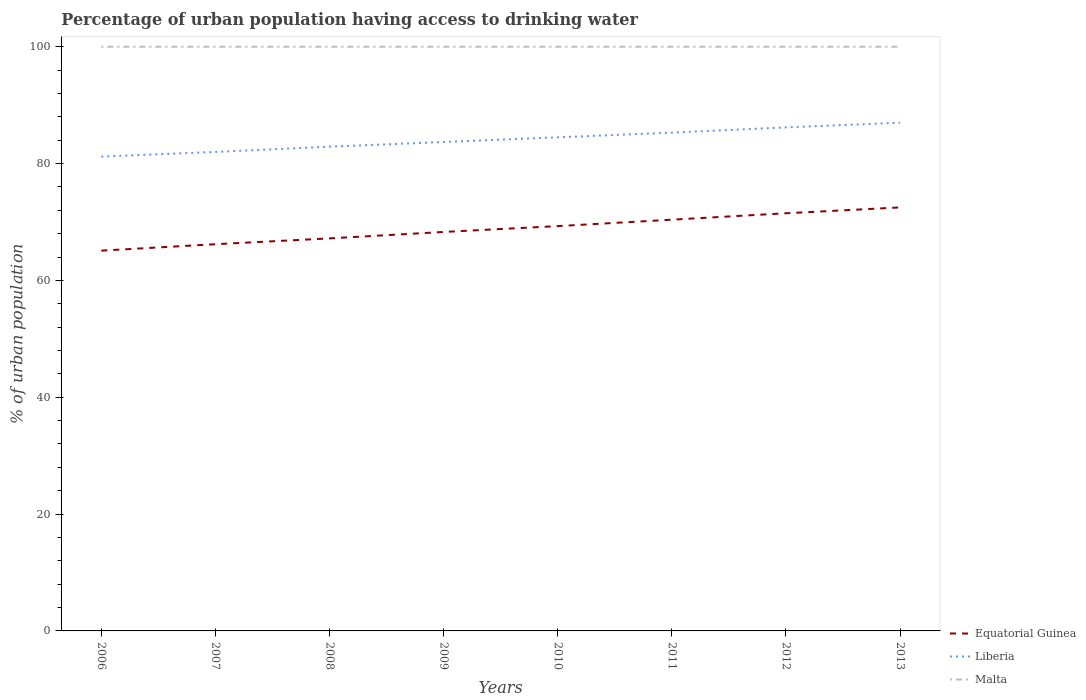Across all years, what is the maximum percentage of urban population having access to drinking water in Liberia?
Provide a succinct answer. 81.2. What is the total percentage of urban population having access to drinking water in Liberia in the graph?
Give a very brief answer. -1.7. What is the difference between the highest and the second highest percentage of urban population having access to drinking water in Liberia?
Give a very brief answer. 5.8. What is the difference between the highest and the lowest percentage of urban population having access to drinking water in Equatorial Guinea?
Your answer should be compact. 4. Is the percentage of urban population having access to drinking water in Malta strictly greater than the percentage of urban population having access to drinking water in Liberia over the years?
Keep it short and to the point. No. How many lines are there?
Offer a very short reply. 3. How many years are there in the graph?
Offer a very short reply. 8. Where does the legend appear in the graph?
Your answer should be compact. Bottom right. What is the title of the graph?
Provide a succinct answer. Percentage of urban population having access to drinking water. What is the label or title of the X-axis?
Offer a very short reply. Years. What is the label or title of the Y-axis?
Give a very brief answer. % of urban population. What is the % of urban population in Equatorial Guinea in 2006?
Ensure brevity in your answer.  65.1. What is the % of urban population in Liberia in 2006?
Offer a terse response. 81.2. What is the % of urban population of Malta in 2006?
Your answer should be compact. 100. What is the % of urban population in Equatorial Guinea in 2007?
Provide a succinct answer. 66.2. What is the % of urban population in Malta in 2007?
Ensure brevity in your answer.  100. What is the % of urban population of Equatorial Guinea in 2008?
Your response must be concise. 67.2. What is the % of urban population of Liberia in 2008?
Your answer should be very brief. 82.9. What is the % of urban population in Equatorial Guinea in 2009?
Your answer should be compact. 68.3. What is the % of urban population in Liberia in 2009?
Your answer should be very brief. 83.7. What is the % of urban population in Equatorial Guinea in 2010?
Your answer should be very brief. 69.3. What is the % of urban population of Liberia in 2010?
Keep it short and to the point. 84.5. What is the % of urban population of Equatorial Guinea in 2011?
Your answer should be compact. 70.4. What is the % of urban population in Liberia in 2011?
Offer a very short reply. 85.3. What is the % of urban population of Equatorial Guinea in 2012?
Provide a short and direct response. 71.5. What is the % of urban population of Liberia in 2012?
Your answer should be very brief. 86.2. What is the % of urban population of Malta in 2012?
Your response must be concise. 100. What is the % of urban population of Equatorial Guinea in 2013?
Your answer should be very brief. 72.5. What is the % of urban population in Liberia in 2013?
Your answer should be compact. 87. What is the % of urban population of Malta in 2013?
Make the answer very short. 100. Across all years, what is the maximum % of urban population in Equatorial Guinea?
Offer a very short reply. 72.5. Across all years, what is the maximum % of urban population of Malta?
Provide a succinct answer. 100. Across all years, what is the minimum % of urban population of Equatorial Guinea?
Offer a very short reply. 65.1. Across all years, what is the minimum % of urban population in Liberia?
Offer a very short reply. 81.2. What is the total % of urban population of Equatorial Guinea in the graph?
Offer a very short reply. 550.5. What is the total % of urban population in Liberia in the graph?
Make the answer very short. 672.8. What is the total % of urban population in Malta in the graph?
Your response must be concise. 800. What is the difference between the % of urban population in Malta in 2006 and that in 2007?
Offer a very short reply. 0. What is the difference between the % of urban population of Equatorial Guinea in 2006 and that in 2008?
Ensure brevity in your answer.  -2.1. What is the difference between the % of urban population of Malta in 2006 and that in 2008?
Provide a succinct answer. 0. What is the difference between the % of urban population of Malta in 2006 and that in 2009?
Your answer should be compact. 0. What is the difference between the % of urban population in Equatorial Guinea in 2006 and that in 2011?
Make the answer very short. -5.3. What is the difference between the % of urban population of Equatorial Guinea in 2006 and that in 2012?
Your response must be concise. -6.4. What is the difference between the % of urban population of Malta in 2006 and that in 2012?
Your response must be concise. 0. What is the difference between the % of urban population in Equatorial Guinea in 2006 and that in 2013?
Your answer should be very brief. -7.4. What is the difference between the % of urban population in Liberia in 2006 and that in 2013?
Your response must be concise. -5.8. What is the difference between the % of urban population in Malta in 2006 and that in 2013?
Keep it short and to the point. 0. What is the difference between the % of urban population in Equatorial Guinea in 2007 and that in 2008?
Provide a succinct answer. -1. What is the difference between the % of urban population of Malta in 2007 and that in 2008?
Provide a succinct answer. 0. What is the difference between the % of urban population in Malta in 2007 and that in 2009?
Your response must be concise. 0. What is the difference between the % of urban population of Equatorial Guinea in 2007 and that in 2011?
Your response must be concise. -4.2. What is the difference between the % of urban population in Liberia in 2007 and that in 2011?
Make the answer very short. -3.3. What is the difference between the % of urban population of Malta in 2007 and that in 2011?
Offer a terse response. 0. What is the difference between the % of urban population of Equatorial Guinea in 2007 and that in 2012?
Your answer should be very brief. -5.3. What is the difference between the % of urban population in Equatorial Guinea in 2007 and that in 2013?
Ensure brevity in your answer.  -6.3. What is the difference between the % of urban population of Liberia in 2007 and that in 2013?
Provide a short and direct response. -5. What is the difference between the % of urban population in Malta in 2007 and that in 2013?
Your answer should be compact. 0. What is the difference between the % of urban population in Equatorial Guinea in 2008 and that in 2009?
Provide a short and direct response. -1.1. What is the difference between the % of urban population in Liberia in 2008 and that in 2009?
Offer a very short reply. -0.8. What is the difference between the % of urban population in Equatorial Guinea in 2008 and that in 2010?
Give a very brief answer. -2.1. What is the difference between the % of urban population of Liberia in 2008 and that in 2010?
Provide a short and direct response. -1.6. What is the difference between the % of urban population of Malta in 2008 and that in 2010?
Provide a succinct answer. 0. What is the difference between the % of urban population of Equatorial Guinea in 2008 and that in 2011?
Provide a short and direct response. -3.2. What is the difference between the % of urban population in Equatorial Guinea in 2008 and that in 2012?
Your response must be concise. -4.3. What is the difference between the % of urban population in Equatorial Guinea in 2008 and that in 2013?
Your answer should be compact. -5.3. What is the difference between the % of urban population of Equatorial Guinea in 2009 and that in 2010?
Provide a short and direct response. -1. What is the difference between the % of urban population of Malta in 2009 and that in 2010?
Provide a succinct answer. 0. What is the difference between the % of urban population of Malta in 2009 and that in 2011?
Your answer should be very brief. 0. What is the difference between the % of urban population in Liberia in 2009 and that in 2012?
Ensure brevity in your answer.  -2.5. What is the difference between the % of urban population of Equatorial Guinea in 2009 and that in 2013?
Offer a very short reply. -4.2. What is the difference between the % of urban population of Liberia in 2009 and that in 2013?
Provide a short and direct response. -3.3. What is the difference between the % of urban population of Equatorial Guinea in 2010 and that in 2011?
Ensure brevity in your answer.  -1.1. What is the difference between the % of urban population of Equatorial Guinea in 2010 and that in 2012?
Offer a terse response. -2.2. What is the difference between the % of urban population in Liberia in 2010 and that in 2012?
Your response must be concise. -1.7. What is the difference between the % of urban population of Malta in 2010 and that in 2012?
Keep it short and to the point. 0. What is the difference between the % of urban population in Malta in 2010 and that in 2013?
Provide a succinct answer. 0. What is the difference between the % of urban population of Liberia in 2011 and that in 2012?
Provide a short and direct response. -0.9. What is the difference between the % of urban population in Malta in 2011 and that in 2012?
Your response must be concise. 0. What is the difference between the % of urban population in Equatorial Guinea in 2011 and that in 2013?
Offer a very short reply. -2.1. What is the difference between the % of urban population in Liberia in 2011 and that in 2013?
Give a very brief answer. -1.7. What is the difference between the % of urban population in Equatorial Guinea in 2006 and the % of urban population in Liberia in 2007?
Your answer should be compact. -16.9. What is the difference between the % of urban population in Equatorial Guinea in 2006 and the % of urban population in Malta in 2007?
Provide a succinct answer. -34.9. What is the difference between the % of urban population in Liberia in 2006 and the % of urban population in Malta in 2007?
Ensure brevity in your answer.  -18.8. What is the difference between the % of urban population of Equatorial Guinea in 2006 and the % of urban population of Liberia in 2008?
Your response must be concise. -17.8. What is the difference between the % of urban population in Equatorial Guinea in 2006 and the % of urban population in Malta in 2008?
Provide a short and direct response. -34.9. What is the difference between the % of urban population of Liberia in 2006 and the % of urban population of Malta in 2008?
Your answer should be very brief. -18.8. What is the difference between the % of urban population in Equatorial Guinea in 2006 and the % of urban population in Liberia in 2009?
Offer a terse response. -18.6. What is the difference between the % of urban population in Equatorial Guinea in 2006 and the % of urban population in Malta in 2009?
Give a very brief answer. -34.9. What is the difference between the % of urban population of Liberia in 2006 and the % of urban population of Malta in 2009?
Provide a short and direct response. -18.8. What is the difference between the % of urban population in Equatorial Guinea in 2006 and the % of urban population in Liberia in 2010?
Provide a short and direct response. -19.4. What is the difference between the % of urban population of Equatorial Guinea in 2006 and the % of urban population of Malta in 2010?
Your answer should be very brief. -34.9. What is the difference between the % of urban population of Liberia in 2006 and the % of urban population of Malta in 2010?
Offer a terse response. -18.8. What is the difference between the % of urban population in Equatorial Guinea in 2006 and the % of urban population in Liberia in 2011?
Give a very brief answer. -20.2. What is the difference between the % of urban population in Equatorial Guinea in 2006 and the % of urban population in Malta in 2011?
Provide a succinct answer. -34.9. What is the difference between the % of urban population in Liberia in 2006 and the % of urban population in Malta in 2011?
Your answer should be very brief. -18.8. What is the difference between the % of urban population in Equatorial Guinea in 2006 and the % of urban population in Liberia in 2012?
Offer a terse response. -21.1. What is the difference between the % of urban population in Equatorial Guinea in 2006 and the % of urban population in Malta in 2012?
Offer a very short reply. -34.9. What is the difference between the % of urban population of Liberia in 2006 and the % of urban population of Malta in 2012?
Your response must be concise. -18.8. What is the difference between the % of urban population in Equatorial Guinea in 2006 and the % of urban population in Liberia in 2013?
Give a very brief answer. -21.9. What is the difference between the % of urban population in Equatorial Guinea in 2006 and the % of urban population in Malta in 2013?
Provide a short and direct response. -34.9. What is the difference between the % of urban population in Liberia in 2006 and the % of urban population in Malta in 2013?
Offer a terse response. -18.8. What is the difference between the % of urban population of Equatorial Guinea in 2007 and the % of urban population of Liberia in 2008?
Keep it short and to the point. -16.7. What is the difference between the % of urban population in Equatorial Guinea in 2007 and the % of urban population in Malta in 2008?
Keep it short and to the point. -33.8. What is the difference between the % of urban population of Liberia in 2007 and the % of urban population of Malta in 2008?
Keep it short and to the point. -18. What is the difference between the % of urban population in Equatorial Guinea in 2007 and the % of urban population in Liberia in 2009?
Provide a succinct answer. -17.5. What is the difference between the % of urban population of Equatorial Guinea in 2007 and the % of urban population of Malta in 2009?
Make the answer very short. -33.8. What is the difference between the % of urban population in Liberia in 2007 and the % of urban population in Malta in 2009?
Keep it short and to the point. -18. What is the difference between the % of urban population in Equatorial Guinea in 2007 and the % of urban population in Liberia in 2010?
Offer a terse response. -18.3. What is the difference between the % of urban population of Equatorial Guinea in 2007 and the % of urban population of Malta in 2010?
Your response must be concise. -33.8. What is the difference between the % of urban population in Liberia in 2007 and the % of urban population in Malta in 2010?
Keep it short and to the point. -18. What is the difference between the % of urban population in Equatorial Guinea in 2007 and the % of urban population in Liberia in 2011?
Offer a very short reply. -19.1. What is the difference between the % of urban population of Equatorial Guinea in 2007 and the % of urban population of Malta in 2011?
Provide a short and direct response. -33.8. What is the difference between the % of urban population of Liberia in 2007 and the % of urban population of Malta in 2011?
Ensure brevity in your answer.  -18. What is the difference between the % of urban population of Equatorial Guinea in 2007 and the % of urban population of Malta in 2012?
Ensure brevity in your answer.  -33.8. What is the difference between the % of urban population in Liberia in 2007 and the % of urban population in Malta in 2012?
Your answer should be compact. -18. What is the difference between the % of urban population in Equatorial Guinea in 2007 and the % of urban population in Liberia in 2013?
Your answer should be very brief. -20.8. What is the difference between the % of urban population in Equatorial Guinea in 2007 and the % of urban population in Malta in 2013?
Keep it short and to the point. -33.8. What is the difference between the % of urban population of Liberia in 2007 and the % of urban population of Malta in 2013?
Your answer should be compact. -18. What is the difference between the % of urban population of Equatorial Guinea in 2008 and the % of urban population of Liberia in 2009?
Your response must be concise. -16.5. What is the difference between the % of urban population of Equatorial Guinea in 2008 and the % of urban population of Malta in 2009?
Make the answer very short. -32.8. What is the difference between the % of urban population in Liberia in 2008 and the % of urban population in Malta in 2009?
Offer a very short reply. -17.1. What is the difference between the % of urban population in Equatorial Guinea in 2008 and the % of urban population in Liberia in 2010?
Your response must be concise. -17.3. What is the difference between the % of urban population of Equatorial Guinea in 2008 and the % of urban population of Malta in 2010?
Give a very brief answer. -32.8. What is the difference between the % of urban population in Liberia in 2008 and the % of urban population in Malta in 2010?
Provide a succinct answer. -17.1. What is the difference between the % of urban population of Equatorial Guinea in 2008 and the % of urban population of Liberia in 2011?
Your answer should be compact. -18.1. What is the difference between the % of urban population in Equatorial Guinea in 2008 and the % of urban population in Malta in 2011?
Keep it short and to the point. -32.8. What is the difference between the % of urban population in Liberia in 2008 and the % of urban population in Malta in 2011?
Ensure brevity in your answer.  -17.1. What is the difference between the % of urban population of Equatorial Guinea in 2008 and the % of urban population of Malta in 2012?
Provide a succinct answer. -32.8. What is the difference between the % of urban population of Liberia in 2008 and the % of urban population of Malta in 2012?
Offer a very short reply. -17.1. What is the difference between the % of urban population of Equatorial Guinea in 2008 and the % of urban population of Liberia in 2013?
Your answer should be compact. -19.8. What is the difference between the % of urban population of Equatorial Guinea in 2008 and the % of urban population of Malta in 2013?
Keep it short and to the point. -32.8. What is the difference between the % of urban population of Liberia in 2008 and the % of urban population of Malta in 2013?
Your answer should be very brief. -17.1. What is the difference between the % of urban population of Equatorial Guinea in 2009 and the % of urban population of Liberia in 2010?
Your response must be concise. -16.2. What is the difference between the % of urban population of Equatorial Guinea in 2009 and the % of urban population of Malta in 2010?
Ensure brevity in your answer.  -31.7. What is the difference between the % of urban population in Liberia in 2009 and the % of urban population in Malta in 2010?
Your answer should be very brief. -16.3. What is the difference between the % of urban population in Equatorial Guinea in 2009 and the % of urban population in Liberia in 2011?
Ensure brevity in your answer.  -17. What is the difference between the % of urban population of Equatorial Guinea in 2009 and the % of urban population of Malta in 2011?
Your answer should be very brief. -31.7. What is the difference between the % of urban population of Liberia in 2009 and the % of urban population of Malta in 2011?
Your answer should be very brief. -16.3. What is the difference between the % of urban population in Equatorial Guinea in 2009 and the % of urban population in Liberia in 2012?
Keep it short and to the point. -17.9. What is the difference between the % of urban population in Equatorial Guinea in 2009 and the % of urban population in Malta in 2012?
Ensure brevity in your answer.  -31.7. What is the difference between the % of urban population in Liberia in 2009 and the % of urban population in Malta in 2012?
Make the answer very short. -16.3. What is the difference between the % of urban population of Equatorial Guinea in 2009 and the % of urban population of Liberia in 2013?
Offer a terse response. -18.7. What is the difference between the % of urban population of Equatorial Guinea in 2009 and the % of urban population of Malta in 2013?
Give a very brief answer. -31.7. What is the difference between the % of urban population of Liberia in 2009 and the % of urban population of Malta in 2013?
Make the answer very short. -16.3. What is the difference between the % of urban population in Equatorial Guinea in 2010 and the % of urban population in Malta in 2011?
Ensure brevity in your answer.  -30.7. What is the difference between the % of urban population in Liberia in 2010 and the % of urban population in Malta in 2011?
Your response must be concise. -15.5. What is the difference between the % of urban population of Equatorial Guinea in 2010 and the % of urban population of Liberia in 2012?
Offer a very short reply. -16.9. What is the difference between the % of urban population in Equatorial Guinea in 2010 and the % of urban population in Malta in 2012?
Your answer should be very brief. -30.7. What is the difference between the % of urban population of Liberia in 2010 and the % of urban population of Malta in 2012?
Offer a terse response. -15.5. What is the difference between the % of urban population of Equatorial Guinea in 2010 and the % of urban population of Liberia in 2013?
Your answer should be compact. -17.7. What is the difference between the % of urban population in Equatorial Guinea in 2010 and the % of urban population in Malta in 2013?
Ensure brevity in your answer.  -30.7. What is the difference between the % of urban population in Liberia in 2010 and the % of urban population in Malta in 2013?
Provide a succinct answer. -15.5. What is the difference between the % of urban population in Equatorial Guinea in 2011 and the % of urban population in Liberia in 2012?
Your answer should be compact. -15.8. What is the difference between the % of urban population in Equatorial Guinea in 2011 and the % of urban population in Malta in 2012?
Provide a short and direct response. -29.6. What is the difference between the % of urban population of Liberia in 2011 and the % of urban population of Malta in 2012?
Your response must be concise. -14.7. What is the difference between the % of urban population of Equatorial Guinea in 2011 and the % of urban population of Liberia in 2013?
Your answer should be compact. -16.6. What is the difference between the % of urban population in Equatorial Guinea in 2011 and the % of urban population in Malta in 2013?
Your answer should be very brief. -29.6. What is the difference between the % of urban population of Liberia in 2011 and the % of urban population of Malta in 2013?
Keep it short and to the point. -14.7. What is the difference between the % of urban population of Equatorial Guinea in 2012 and the % of urban population of Liberia in 2013?
Keep it short and to the point. -15.5. What is the difference between the % of urban population in Equatorial Guinea in 2012 and the % of urban population in Malta in 2013?
Provide a short and direct response. -28.5. What is the average % of urban population in Equatorial Guinea per year?
Offer a terse response. 68.81. What is the average % of urban population of Liberia per year?
Your answer should be very brief. 84.1. What is the average % of urban population of Malta per year?
Offer a very short reply. 100. In the year 2006, what is the difference between the % of urban population in Equatorial Guinea and % of urban population in Liberia?
Your answer should be very brief. -16.1. In the year 2006, what is the difference between the % of urban population of Equatorial Guinea and % of urban population of Malta?
Give a very brief answer. -34.9. In the year 2006, what is the difference between the % of urban population of Liberia and % of urban population of Malta?
Offer a very short reply. -18.8. In the year 2007, what is the difference between the % of urban population of Equatorial Guinea and % of urban population of Liberia?
Provide a short and direct response. -15.8. In the year 2007, what is the difference between the % of urban population in Equatorial Guinea and % of urban population in Malta?
Keep it short and to the point. -33.8. In the year 2008, what is the difference between the % of urban population in Equatorial Guinea and % of urban population in Liberia?
Make the answer very short. -15.7. In the year 2008, what is the difference between the % of urban population of Equatorial Guinea and % of urban population of Malta?
Make the answer very short. -32.8. In the year 2008, what is the difference between the % of urban population in Liberia and % of urban population in Malta?
Offer a terse response. -17.1. In the year 2009, what is the difference between the % of urban population of Equatorial Guinea and % of urban population of Liberia?
Make the answer very short. -15.4. In the year 2009, what is the difference between the % of urban population in Equatorial Guinea and % of urban population in Malta?
Your answer should be very brief. -31.7. In the year 2009, what is the difference between the % of urban population of Liberia and % of urban population of Malta?
Your response must be concise. -16.3. In the year 2010, what is the difference between the % of urban population of Equatorial Guinea and % of urban population of Liberia?
Your answer should be very brief. -15.2. In the year 2010, what is the difference between the % of urban population of Equatorial Guinea and % of urban population of Malta?
Make the answer very short. -30.7. In the year 2010, what is the difference between the % of urban population in Liberia and % of urban population in Malta?
Offer a terse response. -15.5. In the year 2011, what is the difference between the % of urban population in Equatorial Guinea and % of urban population in Liberia?
Your response must be concise. -14.9. In the year 2011, what is the difference between the % of urban population of Equatorial Guinea and % of urban population of Malta?
Provide a succinct answer. -29.6. In the year 2011, what is the difference between the % of urban population of Liberia and % of urban population of Malta?
Keep it short and to the point. -14.7. In the year 2012, what is the difference between the % of urban population in Equatorial Guinea and % of urban population in Liberia?
Keep it short and to the point. -14.7. In the year 2012, what is the difference between the % of urban population of Equatorial Guinea and % of urban population of Malta?
Your answer should be compact. -28.5. In the year 2012, what is the difference between the % of urban population of Liberia and % of urban population of Malta?
Ensure brevity in your answer.  -13.8. In the year 2013, what is the difference between the % of urban population of Equatorial Guinea and % of urban population of Liberia?
Offer a terse response. -14.5. In the year 2013, what is the difference between the % of urban population of Equatorial Guinea and % of urban population of Malta?
Ensure brevity in your answer.  -27.5. What is the ratio of the % of urban population of Equatorial Guinea in 2006 to that in 2007?
Your answer should be compact. 0.98. What is the ratio of the % of urban population in Liberia in 2006 to that in 2007?
Your answer should be very brief. 0.99. What is the ratio of the % of urban population of Malta in 2006 to that in 2007?
Offer a terse response. 1. What is the ratio of the % of urban population of Equatorial Guinea in 2006 to that in 2008?
Make the answer very short. 0.97. What is the ratio of the % of urban population in Liberia in 2006 to that in 2008?
Your answer should be compact. 0.98. What is the ratio of the % of urban population in Malta in 2006 to that in 2008?
Provide a short and direct response. 1. What is the ratio of the % of urban population in Equatorial Guinea in 2006 to that in 2009?
Your response must be concise. 0.95. What is the ratio of the % of urban population in Liberia in 2006 to that in 2009?
Keep it short and to the point. 0.97. What is the ratio of the % of urban population of Malta in 2006 to that in 2009?
Your answer should be compact. 1. What is the ratio of the % of urban population of Equatorial Guinea in 2006 to that in 2010?
Provide a short and direct response. 0.94. What is the ratio of the % of urban population of Liberia in 2006 to that in 2010?
Your response must be concise. 0.96. What is the ratio of the % of urban population of Malta in 2006 to that in 2010?
Give a very brief answer. 1. What is the ratio of the % of urban population of Equatorial Guinea in 2006 to that in 2011?
Ensure brevity in your answer.  0.92. What is the ratio of the % of urban population of Liberia in 2006 to that in 2011?
Keep it short and to the point. 0.95. What is the ratio of the % of urban population in Malta in 2006 to that in 2011?
Your answer should be compact. 1. What is the ratio of the % of urban population in Equatorial Guinea in 2006 to that in 2012?
Keep it short and to the point. 0.91. What is the ratio of the % of urban population in Liberia in 2006 to that in 2012?
Offer a very short reply. 0.94. What is the ratio of the % of urban population of Equatorial Guinea in 2006 to that in 2013?
Make the answer very short. 0.9. What is the ratio of the % of urban population of Liberia in 2006 to that in 2013?
Your answer should be very brief. 0.93. What is the ratio of the % of urban population in Equatorial Guinea in 2007 to that in 2008?
Make the answer very short. 0.99. What is the ratio of the % of urban population in Liberia in 2007 to that in 2008?
Your response must be concise. 0.99. What is the ratio of the % of urban population in Equatorial Guinea in 2007 to that in 2009?
Provide a succinct answer. 0.97. What is the ratio of the % of urban population in Liberia in 2007 to that in 2009?
Your answer should be compact. 0.98. What is the ratio of the % of urban population in Equatorial Guinea in 2007 to that in 2010?
Keep it short and to the point. 0.96. What is the ratio of the % of urban population of Liberia in 2007 to that in 2010?
Your response must be concise. 0.97. What is the ratio of the % of urban population in Equatorial Guinea in 2007 to that in 2011?
Keep it short and to the point. 0.94. What is the ratio of the % of urban population of Liberia in 2007 to that in 2011?
Your answer should be very brief. 0.96. What is the ratio of the % of urban population of Malta in 2007 to that in 2011?
Your answer should be very brief. 1. What is the ratio of the % of urban population in Equatorial Guinea in 2007 to that in 2012?
Offer a terse response. 0.93. What is the ratio of the % of urban population in Liberia in 2007 to that in 2012?
Ensure brevity in your answer.  0.95. What is the ratio of the % of urban population of Malta in 2007 to that in 2012?
Offer a very short reply. 1. What is the ratio of the % of urban population in Equatorial Guinea in 2007 to that in 2013?
Make the answer very short. 0.91. What is the ratio of the % of urban population in Liberia in 2007 to that in 2013?
Your response must be concise. 0.94. What is the ratio of the % of urban population in Equatorial Guinea in 2008 to that in 2009?
Your response must be concise. 0.98. What is the ratio of the % of urban population in Liberia in 2008 to that in 2009?
Give a very brief answer. 0.99. What is the ratio of the % of urban population in Malta in 2008 to that in 2009?
Your answer should be very brief. 1. What is the ratio of the % of urban population in Equatorial Guinea in 2008 to that in 2010?
Keep it short and to the point. 0.97. What is the ratio of the % of urban population in Liberia in 2008 to that in 2010?
Offer a terse response. 0.98. What is the ratio of the % of urban population in Equatorial Guinea in 2008 to that in 2011?
Provide a succinct answer. 0.95. What is the ratio of the % of urban population in Liberia in 2008 to that in 2011?
Your response must be concise. 0.97. What is the ratio of the % of urban population in Equatorial Guinea in 2008 to that in 2012?
Provide a short and direct response. 0.94. What is the ratio of the % of urban population in Liberia in 2008 to that in 2012?
Your answer should be compact. 0.96. What is the ratio of the % of urban population in Equatorial Guinea in 2008 to that in 2013?
Your answer should be very brief. 0.93. What is the ratio of the % of urban population of Liberia in 2008 to that in 2013?
Offer a terse response. 0.95. What is the ratio of the % of urban population of Equatorial Guinea in 2009 to that in 2010?
Give a very brief answer. 0.99. What is the ratio of the % of urban population in Equatorial Guinea in 2009 to that in 2011?
Your answer should be compact. 0.97. What is the ratio of the % of urban population of Liberia in 2009 to that in 2011?
Offer a terse response. 0.98. What is the ratio of the % of urban population in Malta in 2009 to that in 2011?
Your response must be concise. 1. What is the ratio of the % of urban population of Equatorial Guinea in 2009 to that in 2012?
Make the answer very short. 0.96. What is the ratio of the % of urban population of Malta in 2009 to that in 2012?
Your answer should be compact. 1. What is the ratio of the % of urban population in Equatorial Guinea in 2009 to that in 2013?
Provide a short and direct response. 0.94. What is the ratio of the % of urban population of Liberia in 2009 to that in 2013?
Give a very brief answer. 0.96. What is the ratio of the % of urban population of Malta in 2009 to that in 2013?
Offer a terse response. 1. What is the ratio of the % of urban population of Equatorial Guinea in 2010 to that in 2011?
Give a very brief answer. 0.98. What is the ratio of the % of urban population of Liberia in 2010 to that in 2011?
Ensure brevity in your answer.  0.99. What is the ratio of the % of urban population of Equatorial Guinea in 2010 to that in 2012?
Offer a very short reply. 0.97. What is the ratio of the % of urban population in Liberia in 2010 to that in 2012?
Provide a succinct answer. 0.98. What is the ratio of the % of urban population of Malta in 2010 to that in 2012?
Offer a terse response. 1. What is the ratio of the % of urban population of Equatorial Guinea in 2010 to that in 2013?
Keep it short and to the point. 0.96. What is the ratio of the % of urban population in Liberia in 2010 to that in 2013?
Offer a very short reply. 0.97. What is the ratio of the % of urban population of Equatorial Guinea in 2011 to that in 2012?
Make the answer very short. 0.98. What is the ratio of the % of urban population in Liberia in 2011 to that in 2012?
Your response must be concise. 0.99. What is the ratio of the % of urban population in Equatorial Guinea in 2011 to that in 2013?
Your response must be concise. 0.97. What is the ratio of the % of urban population in Liberia in 2011 to that in 2013?
Provide a short and direct response. 0.98. What is the ratio of the % of urban population in Malta in 2011 to that in 2013?
Give a very brief answer. 1. What is the ratio of the % of urban population of Equatorial Guinea in 2012 to that in 2013?
Keep it short and to the point. 0.99. What is the ratio of the % of urban population in Liberia in 2012 to that in 2013?
Your response must be concise. 0.99. What is the ratio of the % of urban population in Malta in 2012 to that in 2013?
Your answer should be compact. 1. What is the difference between the highest and the second highest % of urban population of Liberia?
Offer a terse response. 0.8. What is the difference between the highest and the second highest % of urban population of Malta?
Provide a short and direct response. 0. What is the difference between the highest and the lowest % of urban population in Liberia?
Offer a terse response. 5.8. What is the difference between the highest and the lowest % of urban population of Malta?
Keep it short and to the point. 0. 